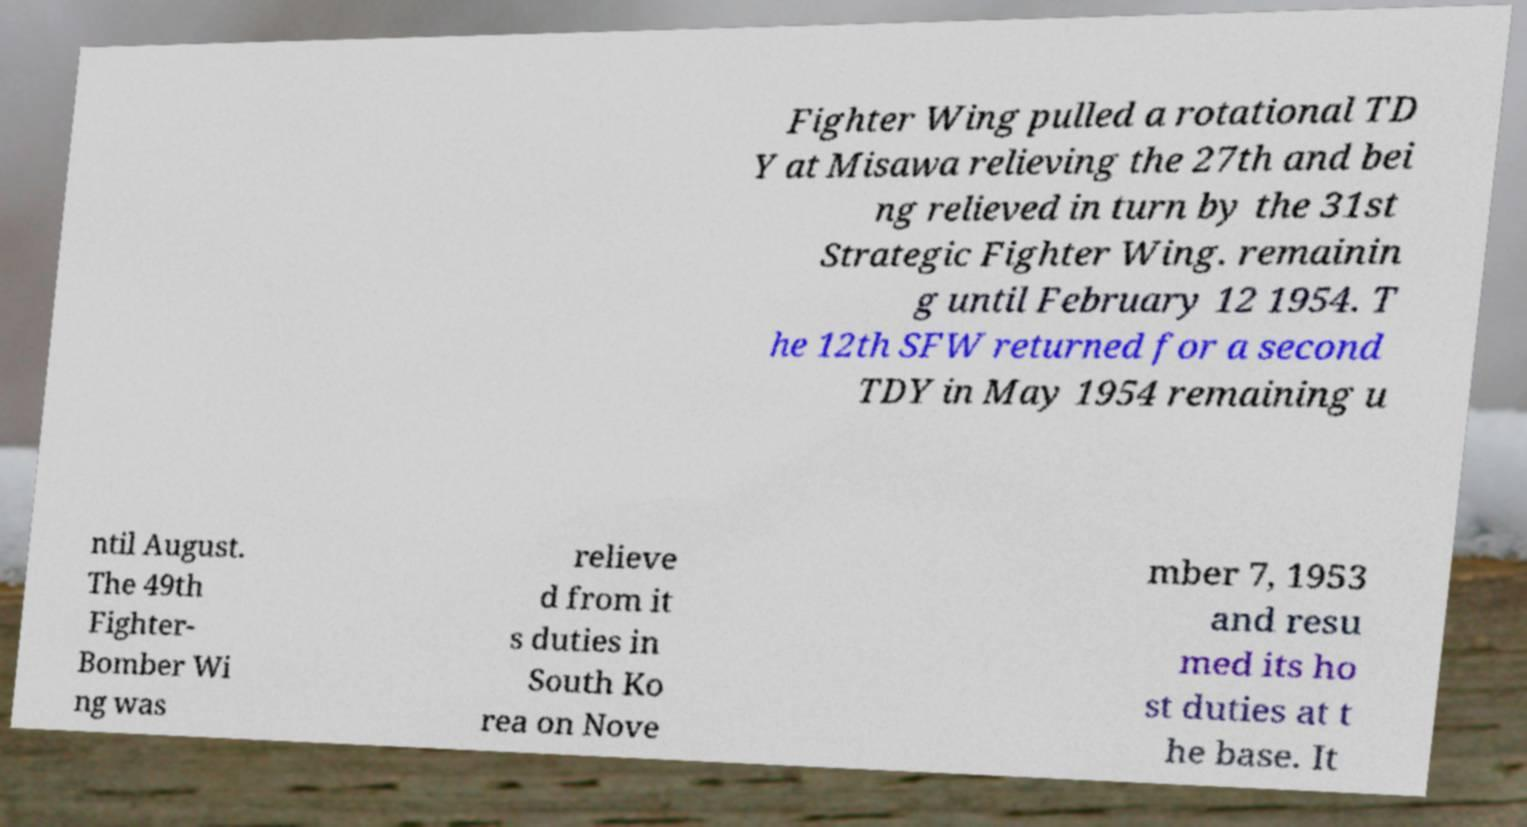Could you extract and type out the text from this image? Fighter Wing pulled a rotational TD Y at Misawa relieving the 27th and bei ng relieved in turn by the 31st Strategic Fighter Wing. remainin g until February 12 1954. T he 12th SFW returned for a second TDY in May 1954 remaining u ntil August. The 49th Fighter- Bomber Wi ng was relieve d from it s duties in South Ko rea on Nove mber 7, 1953 and resu med its ho st duties at t he base. It 